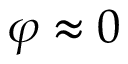<formula> <loc_0><loc_0><loc_500><loc_500>\varphi \approx 0</formula> 